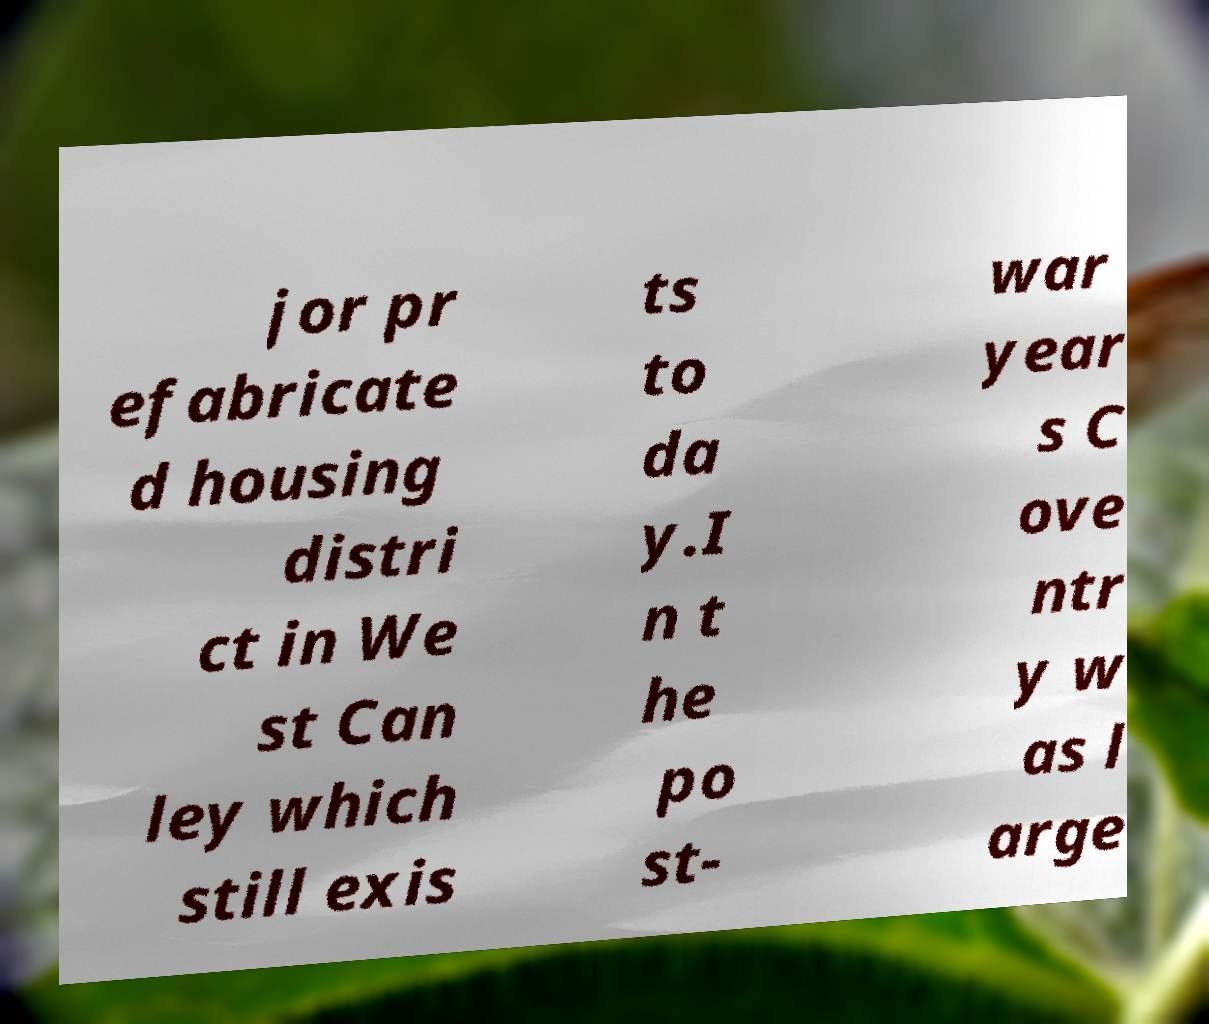What messages or text are displayed in this image? I need them in a readable, typed format. jor pr efabricate d housing distri ct in We st Can ley which still exis ts to da y.I n t he po st- war year s C ove ntr y w as l arge 